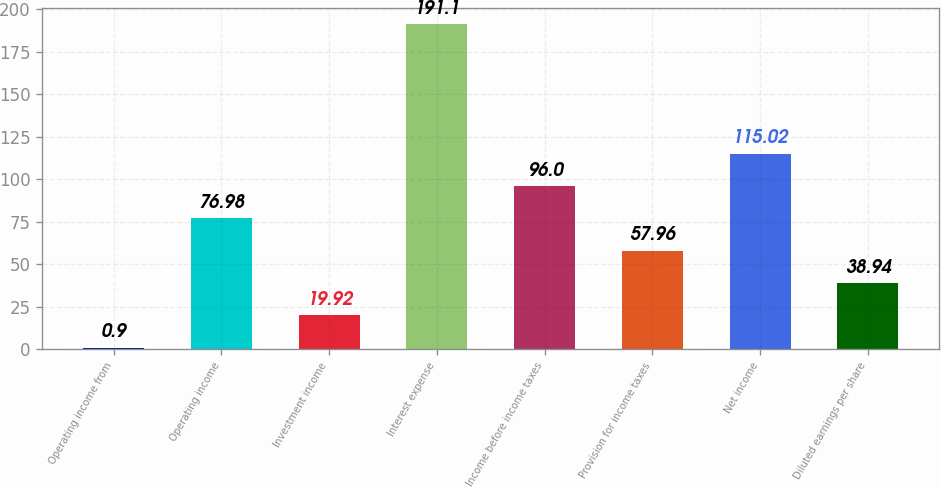<chart> <loc_0><loc_0><loc_500><loc_500><bar_chart><fcel>Operating income from<fcel>Operating income<fcel>Investment income<fcel>Interest expense<fcel>Income before income taxes<fcel>Provision for income taxes<fcel>Net income<fcel>Diluted earnings per share<nl><fcel>0.9<fcel>76.98<fcel>19.92<fcel>191.1<fcel>96<fcel>57.96<fcel>115.02<fcel>38.94<nl></chart> 